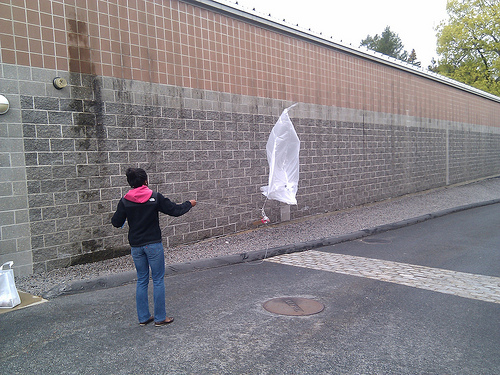<image>
Is there a woman on the sidewalk? No. The woman is not positioned on the sidewalk. They may be near each other, but the woman is not supported by or resting on top of the sidewalk. 